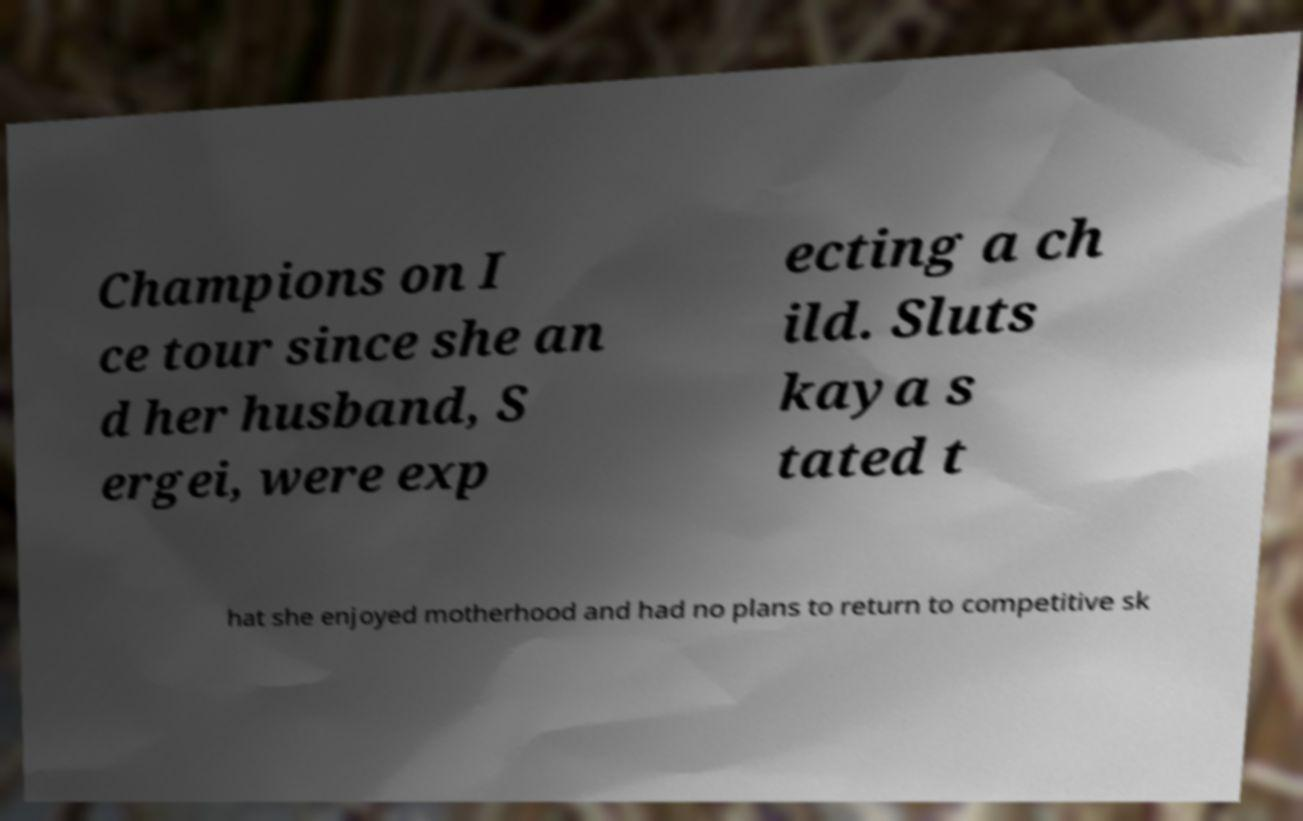Can you accurately transcribe the text from the provided image for me? Champions on I ce tour since she an d her husband, S ergei, were exp ecting a ch ild. Sluts kaya s tated t hat she enjoyed motherhood and had no plans to return to competitive sk 